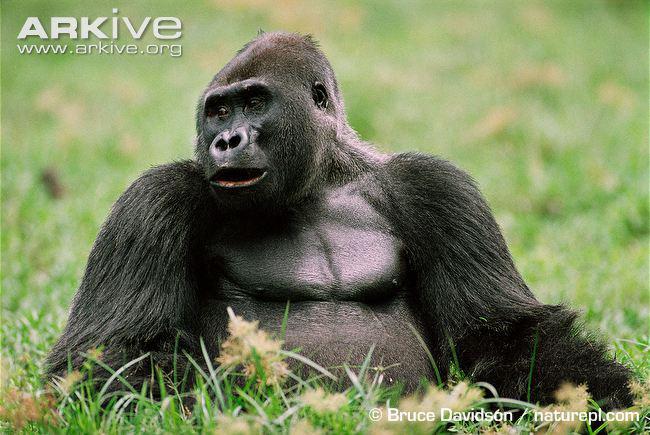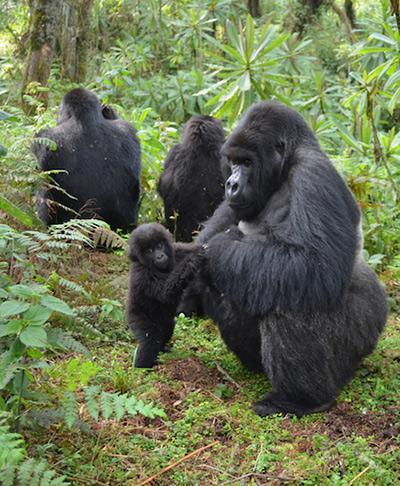The first image is the image on the left, the second image is the image on the right. Examine the images to the left and right. Is the description "An image shows exactly one gorilla, which is posed with its chest facing the camera." accurate? Answer yes or no. Yes. The first image is the image on the left, the second image is the image on the right. Given the left and right images, does the statement "The right image contains no more than two gorillas." hold true? Answer yes or no. No. 